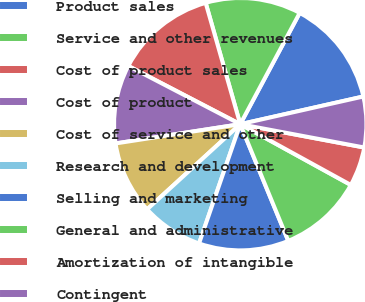<chart> <loc_0><loc_0><loc_500><loc_500><pie_chart><fcel>Product sales<fcel>Service and other revenues<fcel>Cost of product sales<fcel>Cost of product<fcel>Cost of service and other<fcel>Research and development<fcel>Selling and marketing<fcel>General and administrative<fcel>Amortization of intangible<fcel>Contingent<nl><fcel>13.67%<fcel>12.23%<fcel>12.95%<fcel>10.07%<fcel>9.35%<fcel>7.92%<fcel>11.51%<fcel>10.79%<fcel>5.04%<fcel>6.48%<nl></chart> 